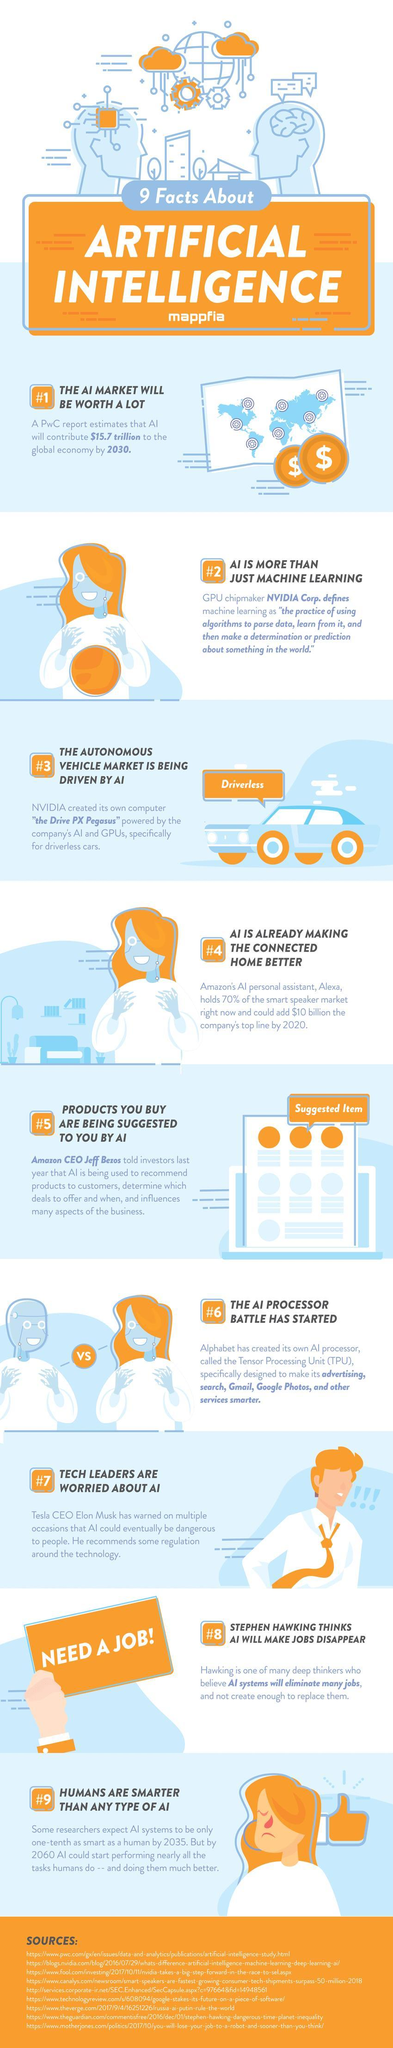What would the AI market worth be, in the next 10 years?
Answer the question with a short phrase. $15.7 trillion Who is the Tech leader who feels that AI will become a danger? Elon Musk The CEO of which company said that AI could make product suggestions? Amazon What is the process of using algorithms for analysing data to make predictions or determinations? Machine learning By which year would artificial intelligence be almost as smart as humans in performing tasks? 2060 Who has developed Alexa? Amazon What is the computer platform for driverless cars and who created it? The drive PX Pegasus, Nvidia Who are smarter, humans or AI? Humans The CEO of which company feels that artificial intelligence could become a danger? Tesla Who has created the TPU? Alphabet Would artificial intelligence result in more jobs or lesser jobs? Lesser jobs 